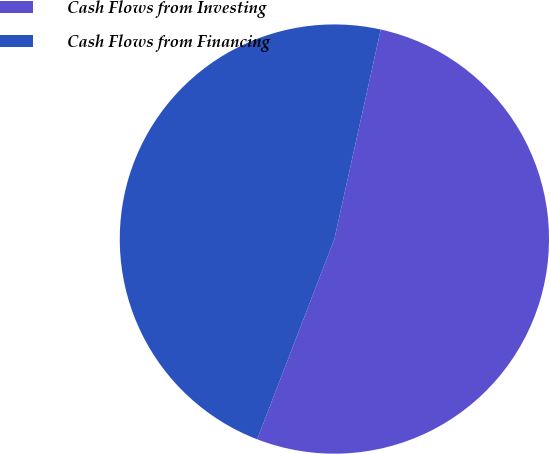<chart> <loc_0><loc_0><loc_500><loc_500><pie_chart><fcel>Cash Flows from Investing<fcel>Cash Flows from Financing<nl><fcel>52.39%<fcel>47.61%<nl></chart> 